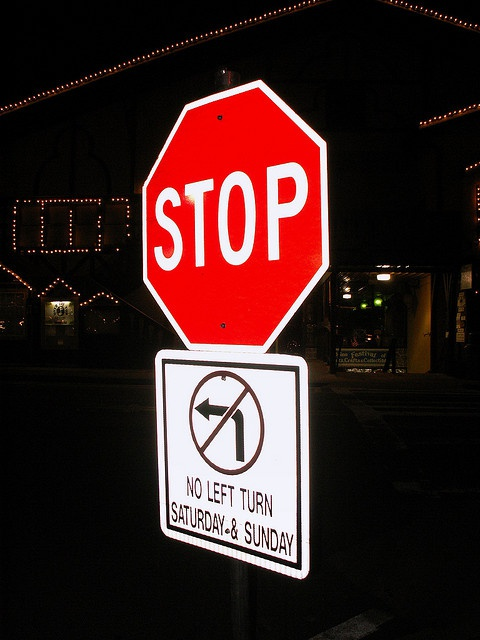Describe the objects in this image and their specific colors. I can see a stop sign in black, red, white, and lightpink tones in this image. 